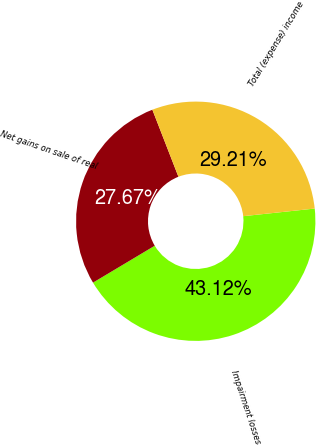<chart> <loc_0><loc_0><loc_500><loc_500><pie_chart><fcel>Impairment losses<fcel>Net gains on sale of real<fcel>Total (expense) income<nl><fcel>43.12%<fcel>27.67%<fcel>29.21%<nl></chart> 